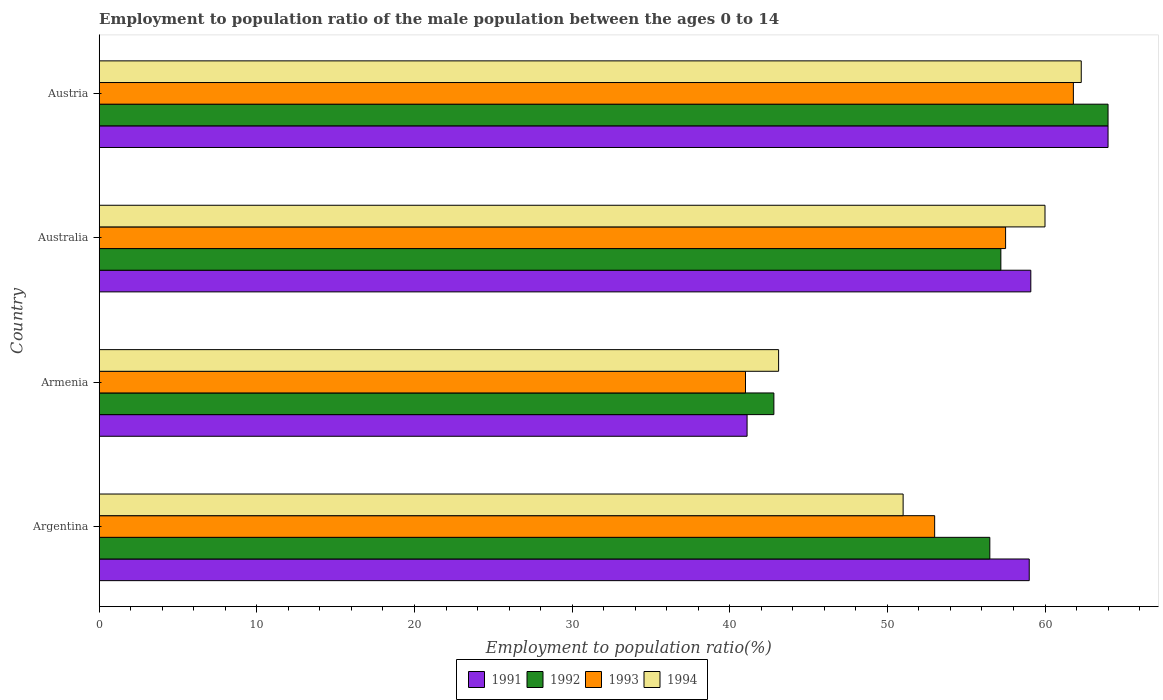Are the number of bars per tick equal to the number of legend labels?
Ensure brevity in your answer.  Yes. Are the number of bars on each tick of the Y-axis equal?
Keep it short and to the point. Yes. How many bars are there on the 3rd tick from the bottom?
Your response must be concise. 4. In how many cases, is the number of bars for a given country not equal to the number of legend labels?
Offer a terse response. 0. What is the employment to population ratio in 1992 in Armenia?
Offer a very short reply. 42.8. Across all countries, what is the maximum employment to population ratio in 1993?
Give a very brief answer. 61.8. Across all countries, what is the minimum employment to population ratio in 1994?
Offer a terse response. 43.1. In which country was the employment to population ratio in 1992 maximum?
Your answer should be compact. Austria. In which country was the employment to population ratio in 1992 minimum?
Give a very brief answer. Armenia. What is the total employment to population ratio in 1991 in the graph?
Ensure brevity in your answer.  223.2. What is the difference between the employment to population ratio in 1992 in Armenia and that in Australia?
Offer a very short reply. -14.4. What is the difference between the employment to population ratio in 1993 in Argentina and the employment to population ratio in 1991 in Australia?
Provide a succinct answer. -6.1. What is the average employment to population ratio in 1994 per country?
Provide a succinct answer. 54.1. What is the ratio of the employment to population ratio in 1992 in Argentina to that in Austria?
Your answer should be compact. 0.88. Is the difference between the employment to population ratio in 1994 in Argentina and Australia greater than the difference between the employment to population ratio in 1992 in Argentina and Australia?
Make the answer very short. No. What is the difference between the highest and the second highest employment to population ratio in 1994?
Keep it short and to the point. 2.3. What is the difference between the highest and the lowest employment to population ratio in 1993?
Your answer should be very brief. 20.8. In how many countries, is the employment to population ratio in 1993 greater than the average employment to population ratio in 1993 taken over all countries?
Offer a very short reply. 2. Is the sum of the employment to population ratio in 1994 in Argentina and Armenia greater than the maximum employment to population ratio in 1991 across all countries?
Your response must be concise. Yes. What does the 2nd bar from the bottom in Armenia represents?
Give a very brief answer. 1992. Are the values on the major ticks of X-axis written in scientific E-notation?
Provide a short and direct response. No. Does the graph contain any zero values?
Your answer should be very brief. No. Does the graph contain grids?
Make the answer very short. No. Where does the legend appear in the graph?
Keep it short and to the point. Bottom center. What is the title of the graph?
Your answer should be compact. Employment to population ratio of the male population between the ages 0 to 14. Does "2011" appear as one of the legend labels in the graph?
Make the answer very short. No. What is the Employment to population ratio(%) of 1991 in Argentina?
Make the answer very short. 59. What is the Employment to population ratio(%) of 1992 in Argentina?
Provide a short and direct response. 56.5. What is the Employment to population ratio(%) in 1993 in Argentina?
Your answer should be compact. 53. What is the Employment to population ratio(%) of 1991 in Armenia?
Ensure brevity in your answer.  41.1. What is the Employment to population ratio(%) of 1992 in Armenia?
Your answer should be very brief. 42.8. What is the Employment to population ratio(%) in 1993 in Armenia?
Offer a very short reply. 41. What is the Employment to population ratio(%) of 1994 in Armenia?
Offer a very short reply. 43.1. What is the Employment to population ratio(%) in 1991 in Australia?
Your answer should be very brief. 59.1. What is the Employment to population ratio(%) in 1992 in Australia?
Your response must be concise. 57.2. What is the Employment to population ratio(%) in 1993 in Australia?
Provide a succinct answer. 57.5. What is the Employment to population ratio(%) in 1991 in Austria?
Offer a very short reply. 64. What is the Employment to population ratio(%) in 1992 in Austria?
Provide a succinct answer. 64. What is the Employment to population ratio(%) of 1993 in Austria?
Your response must be concise. 61.8. What is the Employment to population ratio(%) in 1994 in Austria?
Offer a terse response. 62.3. Across all countries, what is the maximum Employment to population ratio(%) in 1991?
Provide a short and direct response. 64. Across all countries, what is the maximum Employment to population ratio(%) in 1993?
Your answer should be very brief. 61.8. Across all countries, what is the maximum Employment to population ratio(%) in 1994?
Provide a short and direct response. 62.3. Across all countries, what is the minimum Employment to population ratio(%) of 1991?
Your response must be concise. 41.1. Across all countries, what is the minimum Employment to population ratio(%) in 1992?
Your response must be concise. 42.8. Across all countries, what is the minimum Employment to population ratio(%) of 1994?
Your response must be concise. 43.1. What is the total Employment to population ratio(%) of 1991 in the graph?
Provide a succinct answer. 223.2. What is the total Employment to population ratio(%) of 1992 in the graph?
Give a very brief answer. 220.5. What is the total Employment to population ratio(%) in 1993 in the graph?
Give a very brief answer. 213.3. What is the total Employment to population ratio(%) in 1994 in the graph?
Keep it short and to the point. 216.4. What is the difference between the Employment to population ratio(%) of 1992 in Argentina and that in Armenia?
Provide a short and direct response. 13.7. What is the difference between the Employment to population ratio(%) in 1991 in Argentina and that in Australia?
Make the answer very short. -0.1. What is the difference between the Employment to population ratio(%) in 1992 in Argentina and that in Australia?
Your answer should be very brief. -0.7. What is the difference between the Employment to population ratio(%) in 1993 in Argentina and that in Australia?
Offer a very short reply. -4.5. What is the difference between the Employment to population ratio(%) in 1994 in Argentina and that in Australia?
Ensure brevity in your answer.  -9. What is the difference between the Employment to population ratio(%) in 1991 in Argentina and that in Austria?
Give a very brief answer. -5. What is the difference between the Employment to population ratio(%) of 1993 in Argentina and that in Austria?
Provide a short and direct response. -8.8. What is the difference between the Employment to population ratio(%) in 1991 in Armenia and that in Australia?
Ensure brevity in your answer.  -18. What is the difference between the Employment to population ratio(%) in 1992 in Armenia and that in Australia?
Keep it short and to the point. -14.4. What is the difference between the Employment to population ratio(%) in 1993 in Armenia and that in Australia?
Your response must be concise. -16.5. What is the difference between the Employment to population ratio(%) of 1994 in Armenia and that in Australia?
Provide a short and direct response. -16.9. What is the difference between the Employment to population ratio(%) in 1991 in Armenia and that in Austria?
Keep it short and to the point. -22.9. What is the difference between the Employment to population ratio(%) in 1992 in Armenia and that in Austria?
Provide a short and direct response. -21.2. What is the difference between the Employment to population ratio(%) of 1993 in Armenia and that in Austria?
Provide a short and direct response. -20.8. What is the difference between the Employment to population ratio(%) of 1994 in Armenia and that in Austria?
Make the answer very short. -19.2. What is the difference between the Employment to population ratio(%) of 1991 in Australia and that in Austria?
Ensure brevity in your answer.  -4.9. What is the difference between the Employment to population ratio(%) in 1992 in Australia and that in Austria?
Your answer should be very brief. -6.8. What is the difference between the Employment to population ratio(%) of 1993 in Australia and that in Austria?
Provide a succinct answer. -4.3. What is the difference between the Employment to population ratio(%) of 1991 in Argentina and the Employment to population ratio(%) of 1992 in Armenia?
Ensure brevity in your answer.  16.2. What is the difference between the Employment to population ratio(%) of 1991 in Argentina and the Employment to population ratio(%) of 1993 in Armenia?
Offer a very short reply. 18. What is the difference between the Employment to population ratio(%) of 1992 in Argentina and the Employment to population ratio(%) of 1994 in Armenia?
Make the answer very short. 13.4. What is the difference between the Employment to population ratio(%) in 1991 in Argentina and the Employment to population ratio(%) in 1992 in Australia?
Offer a very short reply. 1.8. What is the difference between the Employment to population ratio(%) of 1991 in Argentina and the Employment to population ratio(%) of 1993 in Australia?
Ensure brevity in your answer.  1.5. What is the difference between the Employment to population ratio(%) in 1993 in Argentina and the Employment to population ratio(%) in 1994 in Australia?
Provide a succinct answer. -7. What is the difference between the Employment to population ratio(%) in 1991 in Argentina and the Employment to population ratio(%) in 1993 in Austria?
Ensure brevity in your answer.  -2.8. What is the difference between the Employment to population ratio(%) of 1991 in Argentina and the Employment to population ratio(%) of 1994 in Austria?
Provide a short and direct response. -3.3. What is the difference between the Employment to population ratio(%) of 1992 in Argentina and the Employment to population ratio(%) of 1994 in Austria?
Ensure brevity in your answer.  -5.8. What is the difference between the Employment to population ratio(%) in 1991 in Armenia and the Employment to population ratio(%) in 1992 in Australia?
Your answer should be very brief. -16.1. What is the difference between the Employment to population ratio(%) in 1991 in Armenia and the Employment to population ratio(%) in 1993 in Australia?
Make the answer very short. -16.4. What is the difference between the Employment to population ratio(%) of 1991 in Armenia and the Employment to population ratio(%) of 1994 in Australia?
Give a very brief answer. -18.9. What is the difference between the Employment to population ratio(%) of 1992 in Armenia and the Employment to population ratio(%) of 1993 in Australia?
Make the answer very short. -14.7. What is the difference between the Employment to population ratio(%) of 1992 in Armenia and the Employment to population ratio(%) of 1994 in Australia?
Offer a very short reply. -17.2. What is the difference between the Employment to population ratio(%) in 1991 in Armenia and the Employment to population ratio(%) in 1992 in Austria?
Provide a short and direct response. -22.9. What is the difference between the Employment to population ratio(%) in 1991 in Armenia and the Employment to population ratio(%) in 1993 in Austria?
Your answer should be very brief. -20.7. What is the difference between the Employment to population ratio(%) in 1991 in Armenia and the Employment to population ratio(%) in 1994 in Austria?
Your response must be concise. -21.2. What is the difference between the Employment to population ratio(%) of 1992 in Armenia and the Employment to population ratio(%) of 1994 in Austria?
Your response must be concise. -19.5. What is the difference between the Employment to population ratio(%) in 1993 in Armenia and the Employment to population ratio(%) in 1994 in Austria?
Keep it short and to the point. -21.3. What is the difference between the Employment to population ratio(%) in 1991 in Australia and the Employment to population ratio(%) in 1993 in Austria?
Provide a succinct answer. -2.7. What is the difference between the Employment to population ratio(%) in 1991 in Australia and the Employment to population ratio(%) in 1994 in Austria?
Keep it short and to the point. -3.2. What is the difference between the Employment to population ratio(%) in 1992 in Australia and the Employment to population ratio(%) in 1993 in Austria?
Make the answer very short. -4.6. What is the average Employment to population ratio(%) of 1991 per country?
Offer a very short reply. 55.8. What is the average Employment to population ratio(%) in 1992 per country?
Give a very brief answer. 55.12. What is the average Employment to population ratio(%) in 1993 per country?
Your response must be concise. 53.33. What is the average Employment to population ratio(%) in 1994 per country?
Offer a terse response. 54.1. What is the difference between the Employment to population ratio(%) of 1991 and Employment to population ratio(%) of 1992 in Argentina?
Your answer should be compact. 2.5. What is the difference between the Employment to population ratio(%) of 1991 and Employment to population ratio(%) of 1993 in Argentina?
Provide a succinct answer. 6. What is the difference between the Employment to population ratio(%) of 1991 and Employment to population ratio(%) of 1994 in Argentina?
Provide a succinct answer. 8. What is the difference between the Employment to population ratio(%) in 1991 and Employment to population ratio(%) in 1992 in Armenia?
Provide a succinct answer. -1.7. What is the difference between the Employment to population ratio(%) of 1991 and Employment to population ratio(%) of 1994 in Armenia?
Keep it short and to the point. -2. What is the difference between the Employment to population ratio(%) in 1991 and Employment to population ratio(%) in 1993 in Australia?
Make the answer very short. 1.6. What is the difference between the Employment to population ratio(%) in 1993 and Employment to population ratio(%) in 1994 in Australia?
Make the answer very short. -2.5. What is the difference between the Employment to population ratio(%) of 1991 and Employment to population ratio(%) of 1993 in Austria?
Offer a terse response. 2.2. What is the difference between the Employment to population ratio(%) of 1991 and Employment to population ratio(%) of 1994 in Austria?
Offer a very short reply. 1.7. What is the difference between the Employment to population ratio(%) in 1992 and Employment to population ratio(%) in 1993 in Austria?
Your answer should be very brief. 2.2. What is the difference between the Employment to population ratio(%) of 1993 and Employment to population ratio(%) of 1994 in Austria?
Offer a very short reply. -0.5. What is the ratio of the Employment to population ratio(%) of 1991 in Argentina to that in Armenia?
Ensure brevity in your answer.  1.44. What is the ratio of the Employment to population ratio(%) in 1992 in Argentina to that in Armenia?
Offer a very short reply. 1.32. What is the ratio of the Employment to population ratio(%) in 1993 in Argentina to that in Armenia?
Offer a very short reply. 1.29. What is the ratio of the Employment to population ratio(%) of 1994 in Argentina to that in Armenia?
Your answer should be compact. 1.18. What is the ratio of the Employment to population ratio(%) of 1991 in Argentina to that in Australia?
Offer a terse response. 1. What is the ratio of the Employment to population ratio(%) in 1992 in Argentina to that in Australia?
Make the answer very short. 0.99. What is the ratio of the Employment to population ratio(%) of 1993 in Argentina to that in Australia?
Offer a very short reply. 0.92. What is the ratio of the Employment to population ratio(%) of 1994 in Argentina to that in Australia?
Offer a very short reply. 0.85. What is the ratio of the Employment to population ratio(%) of 1991 in Argentina to that in Austria?
Your answer should be compact. 0.92. What is the ratio of the Employment to population ratio(%) in 1992 in Argentina to that in Austria?
Offer a terse response. 0.88. What is the ratio of the Employment to population ratio(%) in 1993 in Argentina to that in Austria?
Give a very brief answer. 0.86. What is the ratio of the Employment to population ratio(%) in 1994 in Argentina to that in Austria?
Keep it short and to the point. 0.82. What is the ratio of the Employment to population ratio(%) of 1991 in Armenia to that in Australia?
Keep it short and to the point. 0.7. What is the ratio of the Employment to population ratio(%) in 1992 in Armenia to that in Australia?
Your answer should be compact. 0.75. What is the ratio of the Employment to population ratio(%) in 1993 in Armenia to that in Australia?
Offer a terse response. 0.71. What is the ratio of the Employment to population ratio(%) in 1994 in Armenia to that in Australia?
Your response must be concise. 0.72. What is the ratio of the Employment to population ratio(%) of 1991 in Armenia to that in Austria?
Make the answer very short. 0.64. What is the ratio of the Employment to population ratio(%) of 1992 in Armenia to that in Austria?
Make the answer very short. 0.67. What is the ratio of the Employment to population ratio(%) in 1993 in Armenia to that in Austria?
Make the answer very short. 0.66. What is the ratio of the Employment to population ratio(%) in 1994 in Armenia to that in Austria?
Make the answer very short. 0.69. What is the ratio of the Employment to population ratio(%) of 1991 in Australia to that in Austria?
Make the answer very short. 0.92. What is the ratio of the Employment to population ratio(%) of 1992 in Australia to that in Austria?
Your response must be concise. 0.89. What is the ratio of the Employment to population ratio(%) of 1993 in Australia to that in Austria?
Provide a short and direct response. 0.93. What is the ratio of the Employment to population ratio(%) in 1994 in Australia to that in Austria?
Your response must be concise. 0.96. What is the difference between the highest and the second highest Employment to population ratio(%) of 1991?
Offer a terse response. 4.9. What is the difference between the highest and the lowest Employment to population ratio(%) in 1991?
Make the answer very short. 22.9. What is the difference between the highest and the lowest Employment to population ratio(%) of 1992?
Your response must be concise. 21.2. What is the difference between the highest and the lowest Employment to population ratio(%) of 1993?
Make the answer very short. 20.8. What is the difference between the highest and the lowest Employment to population ratio(%) of 1994?
Your response must be concise. 19.2. 